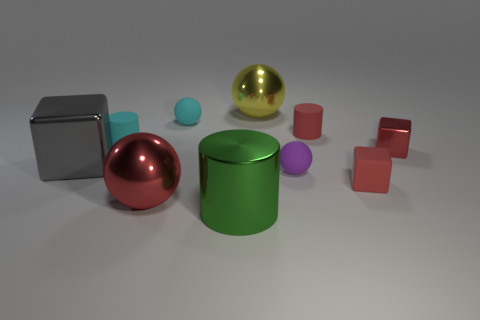Is the number of big shiny things behind the gray metallic object the same as the number of red rubber cylinders that are in front of the cyan matte cylinder?
Provide a short and direct response. No. How many other things are the same color as the tiny shiny thing?
Offer a terse response. 3. Does the small metal block have the same color as the matte cylinder that is to the right of the red sphere?
Keep it short and to the point. Yes. How many brown things are either large shiny spheres or small balls?
Keep it short and to the point. 0. Is the number of small purple matte spheres that are in front of the green metal object the same as the number of green shiny cylinders?
Offer a terse response. No. Are there any other things that have the same size as the cyan matte cylinder?
Ensure brevity in your answer.  Yes. There is another small matte object that is the same shape as the small purple thing; what is its color?
Your answer should be compact. Cyan. What number of gray matte objects are the same shape as the small purple matte object?
Your answer should be compact. 0. There is a large ball that is the same color as the small rubber block; what is it made of?
Offer a very short reply. Metal. What number of large gray metal things are there?
Your answer should be compact. 1. 